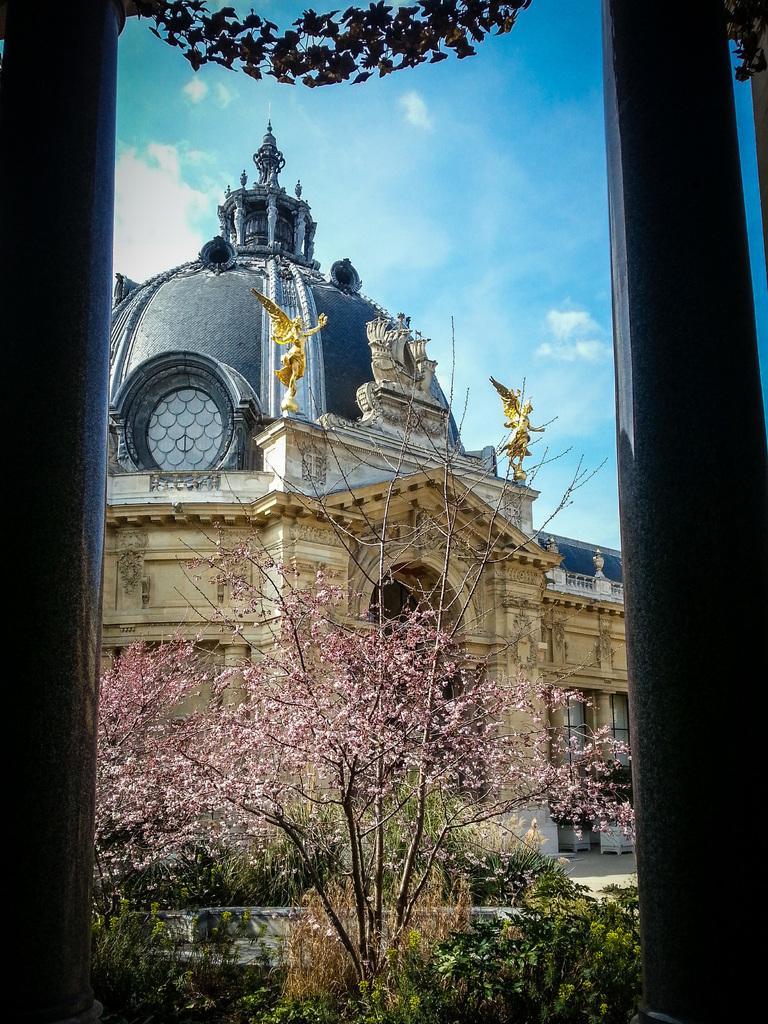Can you describe this image briefly? In this image I can see few trees which are green, brown, black and pink in color. In the background I can see a huge buildings, few statues on the building and the sky. 